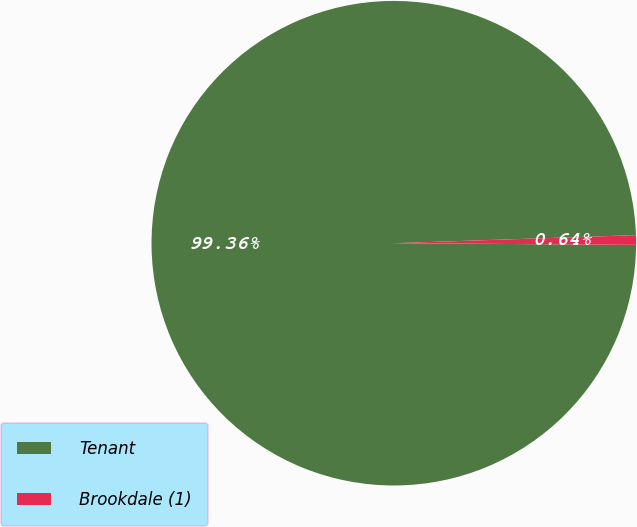<chart> <loc_0><loc_0><loc_500><loc_500><pie_chart><fcel>Tenant<fcel>Brookdale (1)<nl><fcel>99.36%<fcel>0.64%<nl></chart> 